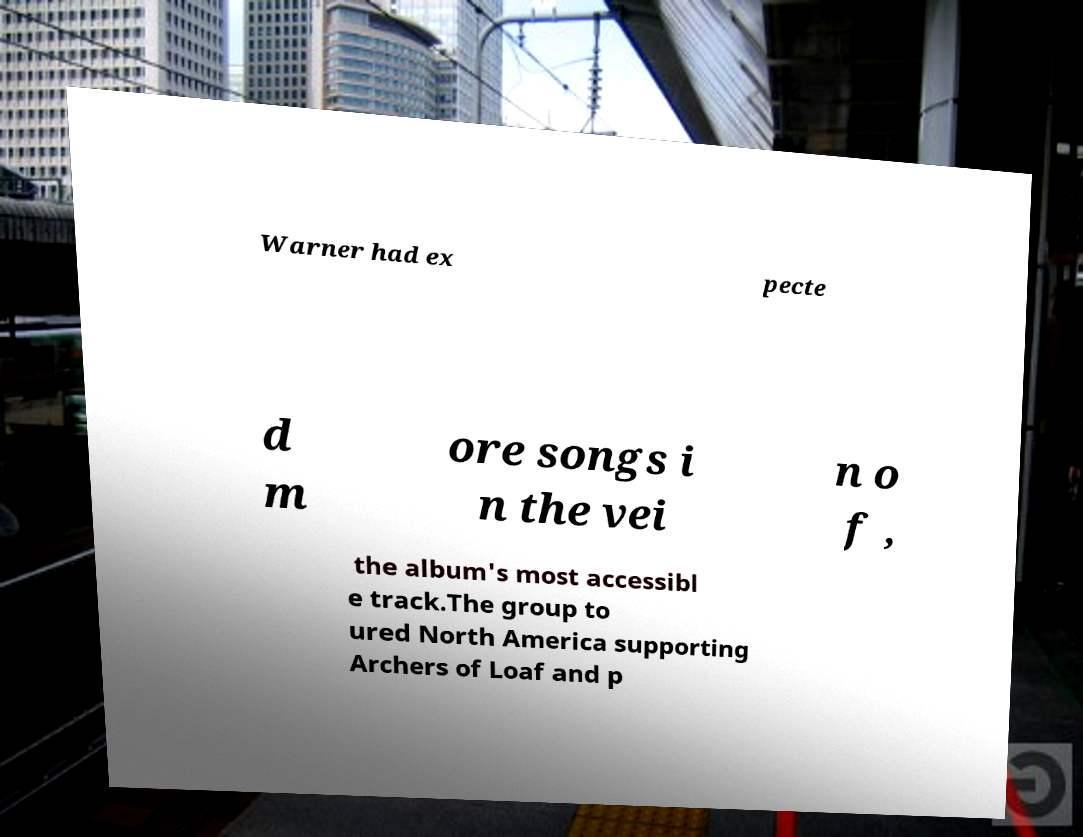I need the written content from this picture converted into text. Can you do that? Warner had ex pecte d m ore songs i n the vei n o f , the album's most accessibl e track.The group to ured North America supporting Archers of Loaf and p 